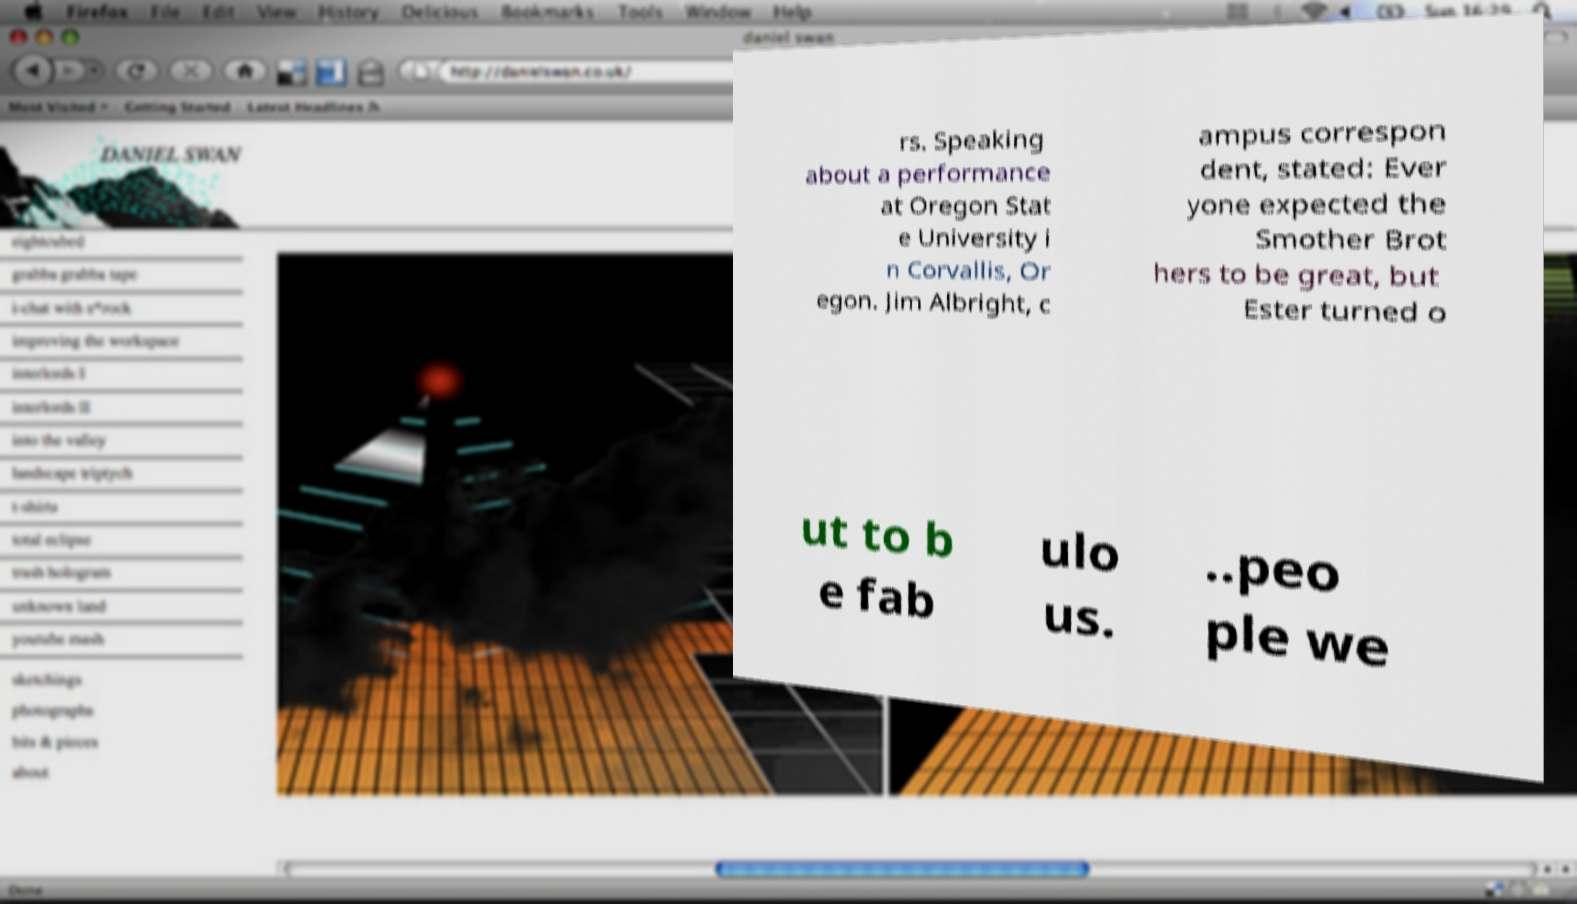Please identify and transcribe the text found in this image. rs. Speaking about a performance at Oregon Stat e University i n Corvallis, Or egon. Jim Albright, c ampus correspon dent, stated: Ever yone expected the Smother Brot hers to be great, but Ester turned o ut to b e fab ulo us. ..peo ple we 